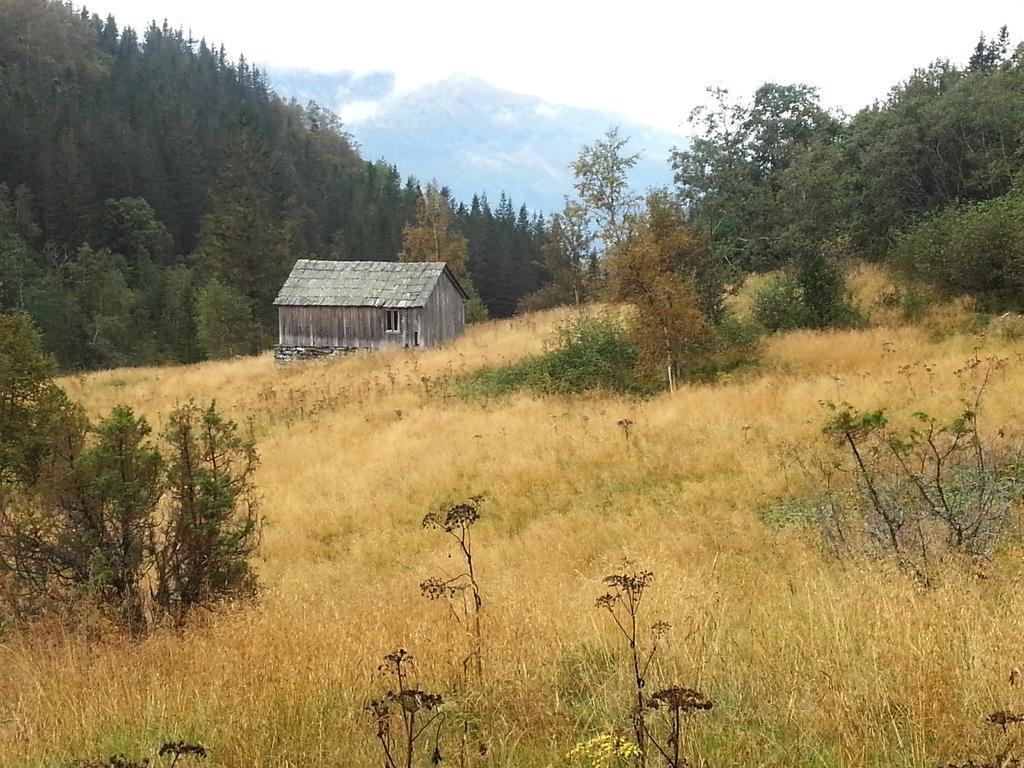In one or two sentences, can you explain what this image depicts? In this image I can see the ash color shade. To the side of the shed I can see the grass and plants. In the background I can see many trees, mountains and the sky. 